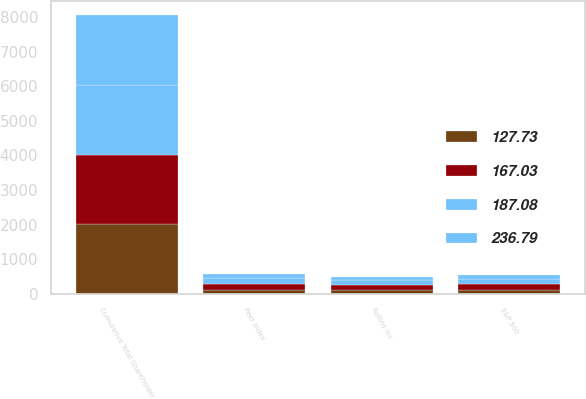Convert chart. <chart><loc_0><loc_0><loc_500><loc_500><stacked_bar_chart><ecel><fcel>Cumulative Total Shareholder<fcel>Rollins Inc<fcel>S&P 500<fcel>Peer Index<nl><fcel>127.73<fcel>2011<fcel>100<fcel>100<fcel>100<nl><fcel>236.79<fcel>2012<fcel>101.06<fcel>116<fcel>127.73<nl><fcel>187.08<fcel>2013<fcel>141.33<fcel>153.57<fcel>167.03<nl><fcel>167.03<fcel>2014<fcel>157.19<fcel>174.6<fcel>187.08<nl></chart> 